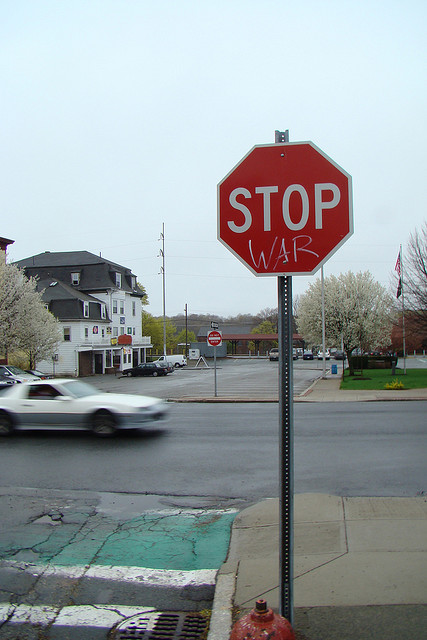Can this form of activism affect local policy changes? This form of street art activism can indeed influence local policy, though it often requires additional mobilization and sustained efforts. By capturing public and media attention, such creations can put pressure on local authorities to address the underlying issues they highlight. While a single altered sign alone might not effect policy change, it can act as a catalyst for community organization, discussions, and broader advocacy efforts that push for substantive changes. 